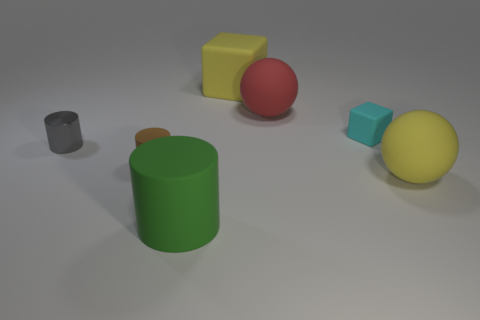Does the sphere in front of the metallic cylinder have the same color as the large rubber block?
Keep it short and to the point. Yes. How many objects are small cylinders or small gray things?
Provide a succinct answer. 2. Is the size of the matte thing in front of the yellow ball the same as the brown object?
Make the answer very short. No. What number of other things are the same size as the brown matte object?
Provide a succinct answer. 2. Is there a green shiny object?
Your answer should be very brief. No. There is a cylinder that is in front of the sphere that is to the right of the red rubber sphere; how big is it?
Offer a very short reply. Large. There is a big matte sphere in front of the small gray cylinder; is it the same color as the block behind the red rubber ball?
Make the answer very short. Yes. What color is the big object that is in front of the cyan matte block and to the left of the large red rubber thing?
Provide a succinct answer. Green. How many other things are the same shape as the green thing?
Provide a short and direct response. 2. What is the color of the rubber block that is the same size as the green matte thing?
Keep it short and to the point. Yellow. 